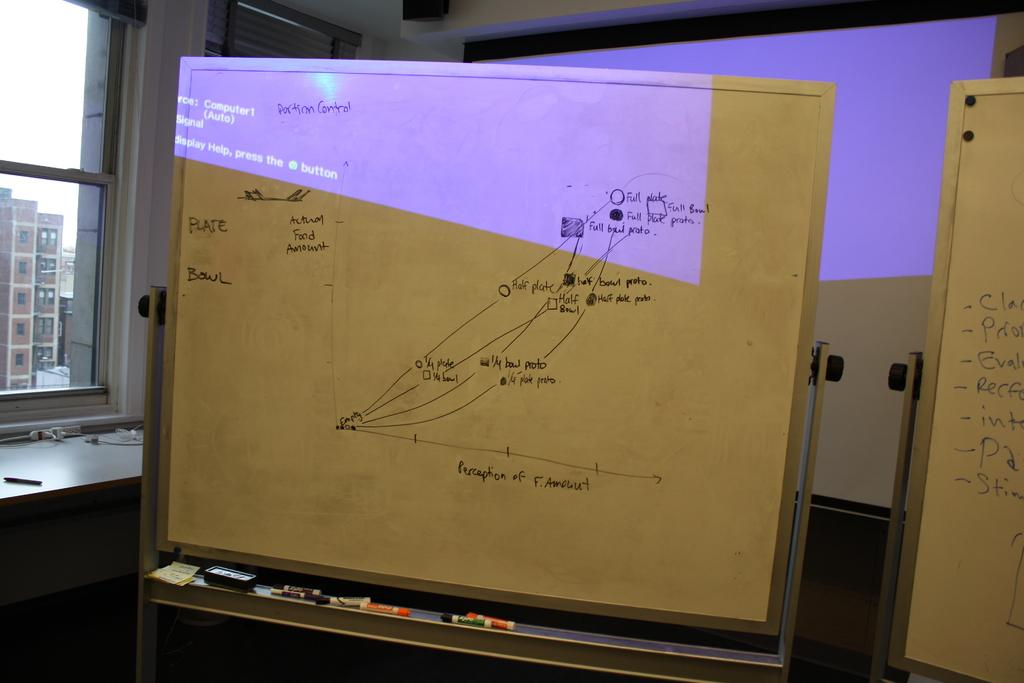What can be seen through the window in the image? The sky is visible through the window in the image. What type of structures are present in the image? There are buildings in the image. What objects are related to writing or drawing in the image? There are boards, pencils, and a board eraser in the image. What architectural feature is present in the image? There is a wall in the image. Can you see a ray of light shining through the window in the image? There is no mention of a ray of light in the provided facts, so we cannot determine if it is present in the image. What type of bird can be seen flying near the buildings in the image? There is no bird present in the image, as mentioned in the provided facts. 